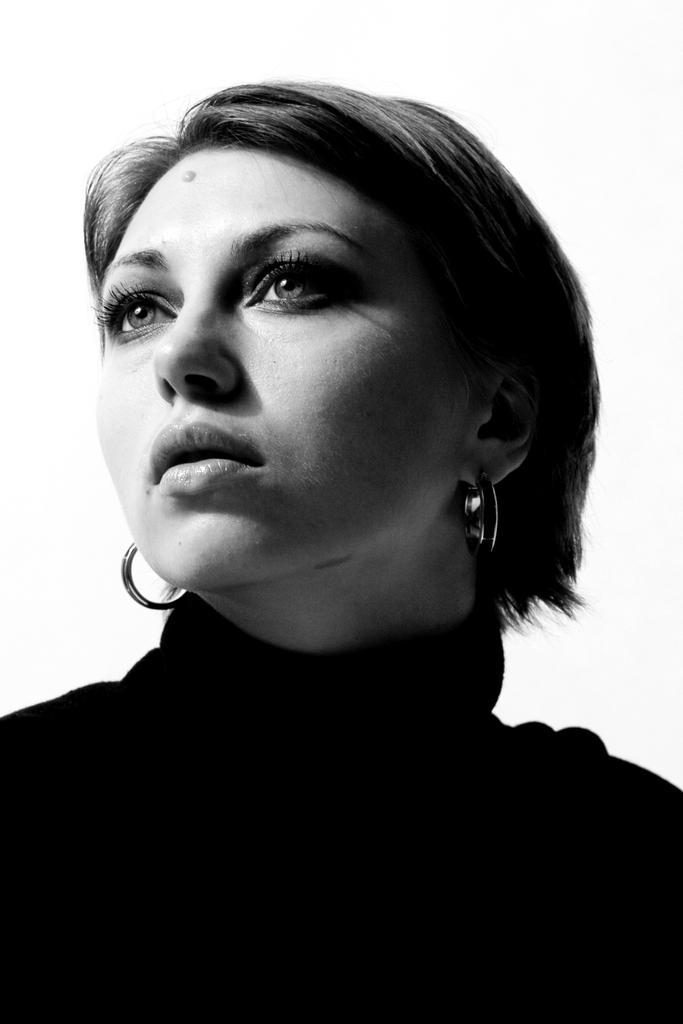Please provide a concise description of this image. In this image I can see a woman and I can see she is wearing earrings. I can also see this image is white and black in colour. 